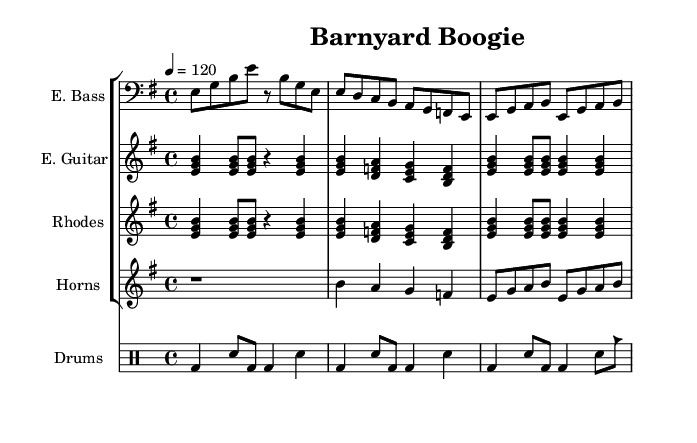What is the key signature of this music? The key signature is E minor, which has one sharp. This can be determined by looking at the key signature indicated at the beginning of the piece, which shows one sharp (F#).
Answer: E minor What is the time signature of this music? The time signature is 4/4, which means there are four beats per measure and the quarter note gets one beat. This information is displayed at the start of the piece.
Answer: 4/4 What is the tempo marking for this music? The tempo marking is 120, indicating that the quarter note should be played at a rate of 120 beats per minute. This is shown in the tempo indication at the beginning.
Answer: 120 What type of instrument is used for the electric bass? The electric bass part is written using a bass clef, indicating that it is a lower-pitched instrument. This can be seen in the notation for the electric bass which is positioned on a staff with a bass clef.
Answer: Bass How many distinct sections are there in this piece of music? The piece contains three sections: Intro, Verse, and Chorus. Each section is differentiated by the musical content and is commonly present in the structure of funk music.
Answer: Three What specific rhythm is used in the drums part during the chorus? The drum part during the chorus primarily uses a kick drum with snare accents, creating a typical funk groove that features a syncopated rhythm. This analysis comes from observing the rhythm notation written for the drum section.
Answer: Kick and snare Which section features the horn instruments predominantly? The Chorus section features the horn instruments predominantly, as noted by the specific musical lines written for the horn section, engaging with the main melody. This is evident because the horn section plays distinct notes during this part.
Answer: Chorus 